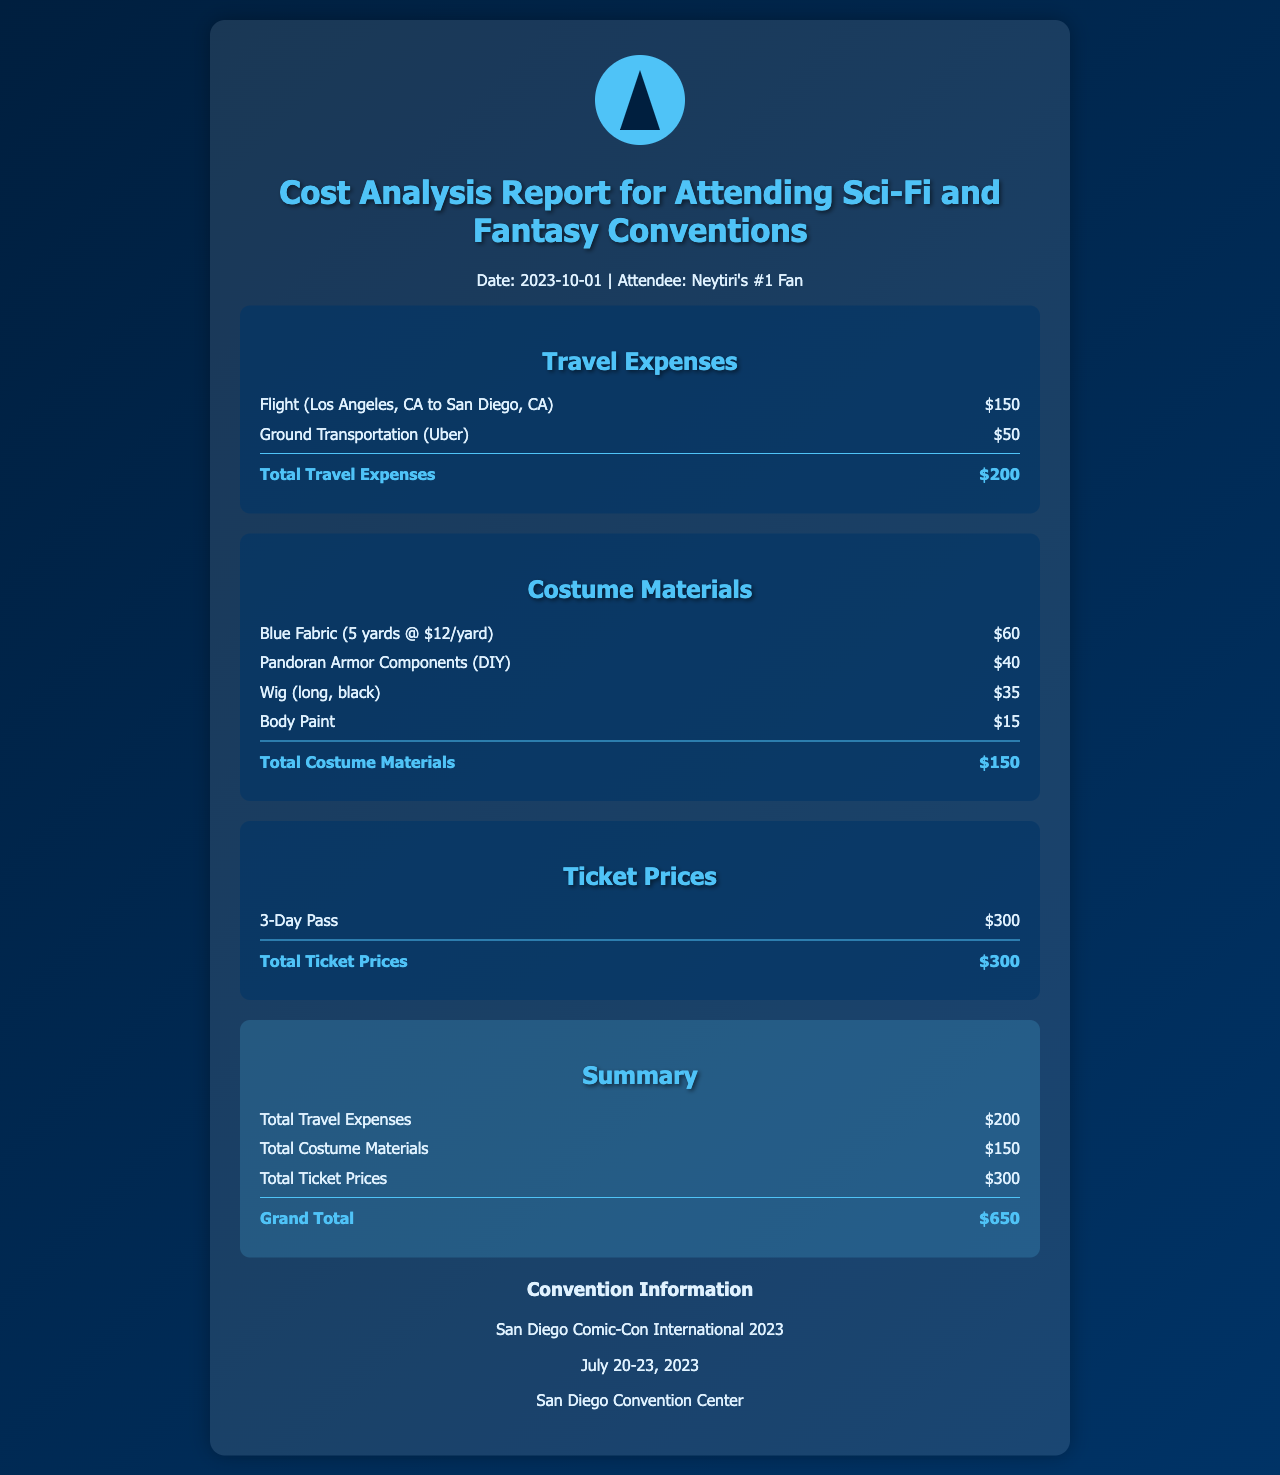What is the total travel expense? The total travel expense is provided in the "Travel Expenses" section of the document, which sums to $200.
Answer: $200 What is the cost of the 3-Day Pass? The ticket price for the 3-Day Pass is listed in the "Ticket Prices" section, and it is $300.
Answer: $300 What are the total costume materials costs? The total cost for costume materials is detailed in the "Costume Materials" section, which totals $150.
Answer: $150 What is the grand total cost for the convention? The grand total combines all expenses from travel, costume materials, and ticket prices, which equals $650.
Answer: $650 When did San Diego Comic-Con International 2023 occur? The convention dates are specified in the document, which state it was from July 20-23, 2023.
Answer: July 20-23, 2023 What is the cost of the Pandoran Armor components? The cost of Pandoran Armor components is found in the "Costume Materials" section and is $40.
Answer: $40 How much did the wig cost? The price for the long, black wig is mentioned in the "Costume Materials" section, which is $35.
Answer: $35 What city is mentioned as the destination for flight travel? The flight destination mentioned in the "Travel Expenses" section is San Diego, CA.
Answer: San Diego, CA What type of body paint cost is listed? The body paint cost listed in the "Costume Materials" section accounts to $15.
Answer: $15 